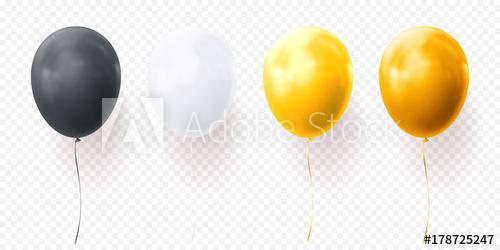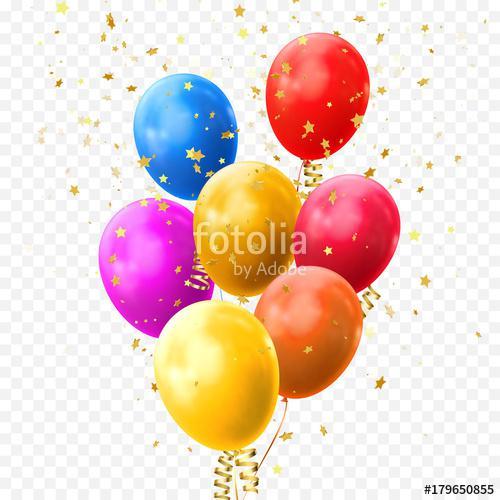The first image is the image on the left, the second image is the image on the right. Examine the images to the left and right. Is the description "One image shows round balloons with dangling, non-straight strings under them, and contains no more than four balloons." accurate? Answer yes or no. Yes. 